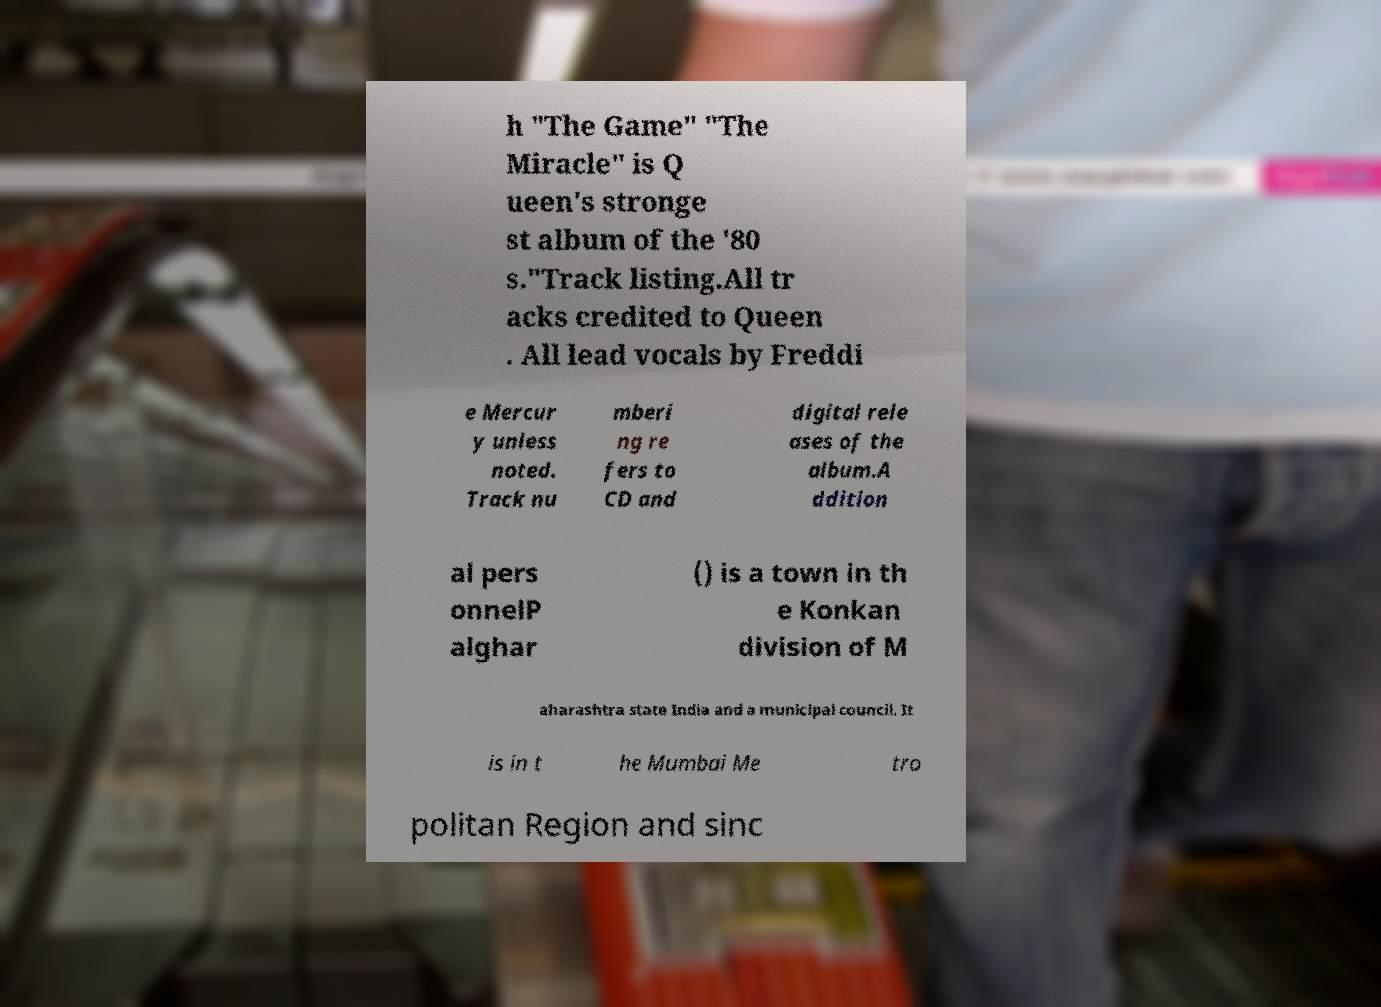Could you extract and type out the text from this image? h "The Game" "The Miracle" is Q ueen's stronge st album of the '80 s."Track listing.All tr acks credited to Queen . All lead vocals by Freddi e Mercur y unless noted. Track nu mberi ng re fers to CD and digital rele ases of the album.A ddition al pers onnelP alghar () is a town in th e Konkan division of M aharashtra state India and a municipal council. It is in t he Mumbai Me tro politan Region and sinc 